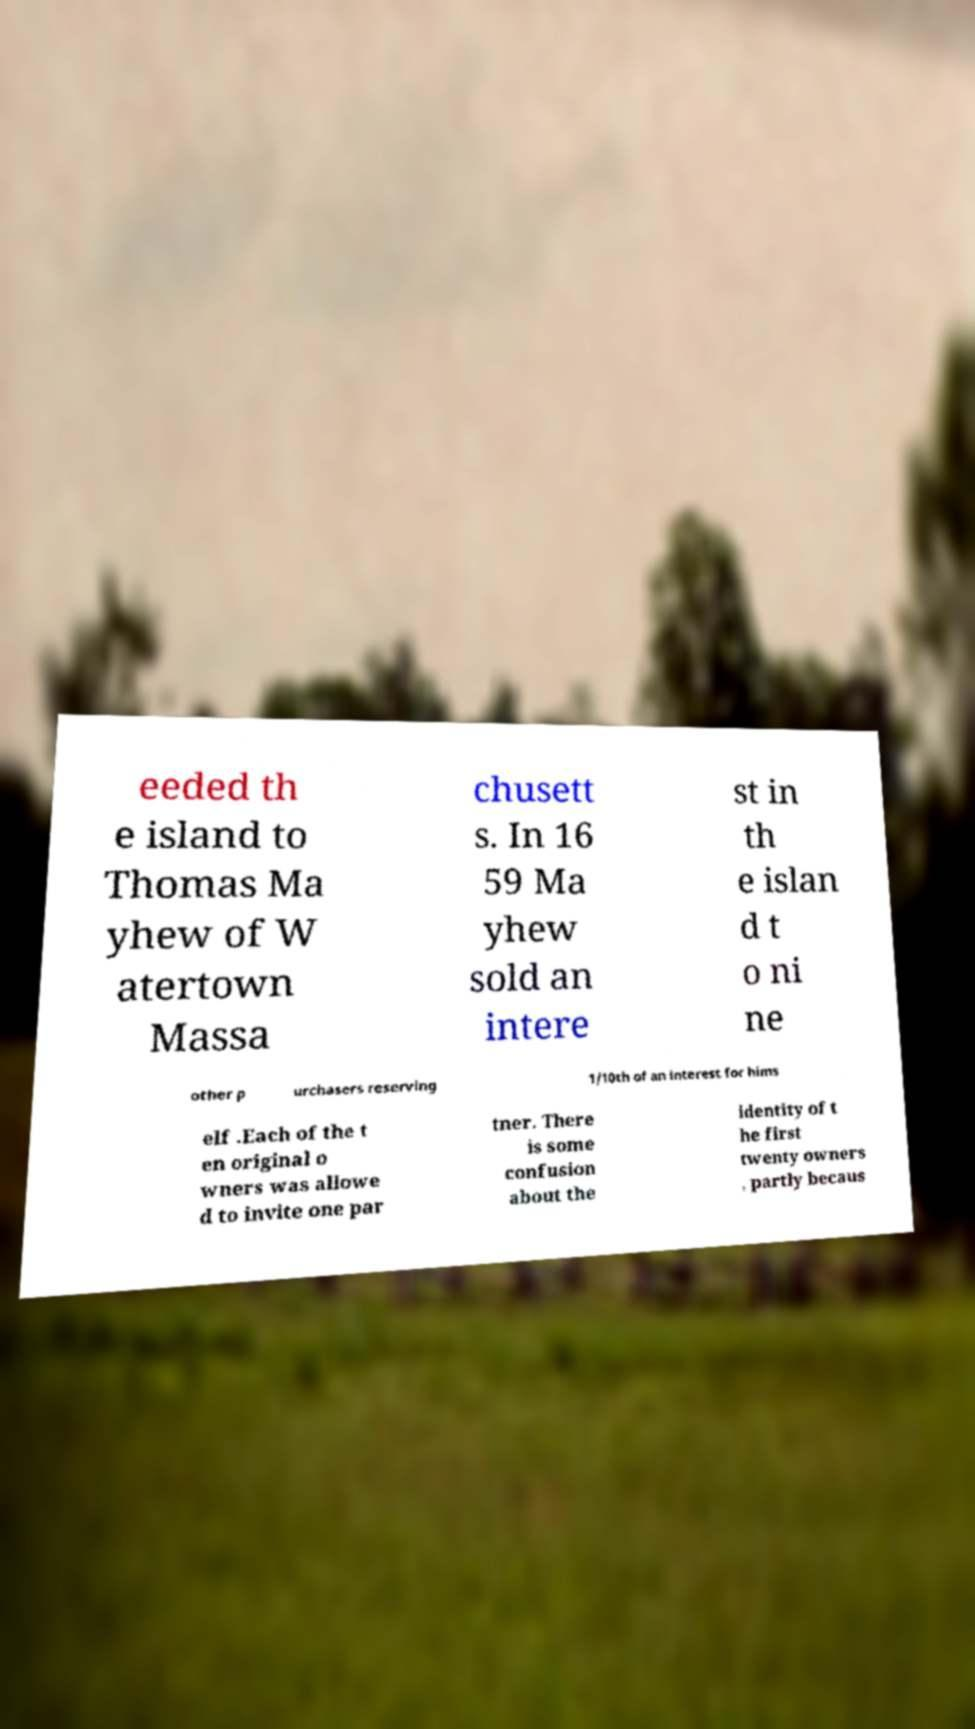There's text embedded in this image that I need extracted. Can you transcribe it verbatim? eeded th e island to Thomas Ma yhew of W atertown Massa chusett s. In 16 59 Ma yhew sold an intere st in th e islan d t o ni ne other p urchasers reserving 1/10th of an interest for hims elf .Each of the t en original o wners was allowe d to invite one par tner. There is some confusion about the identity of t he first twenty owners , partly becaus 